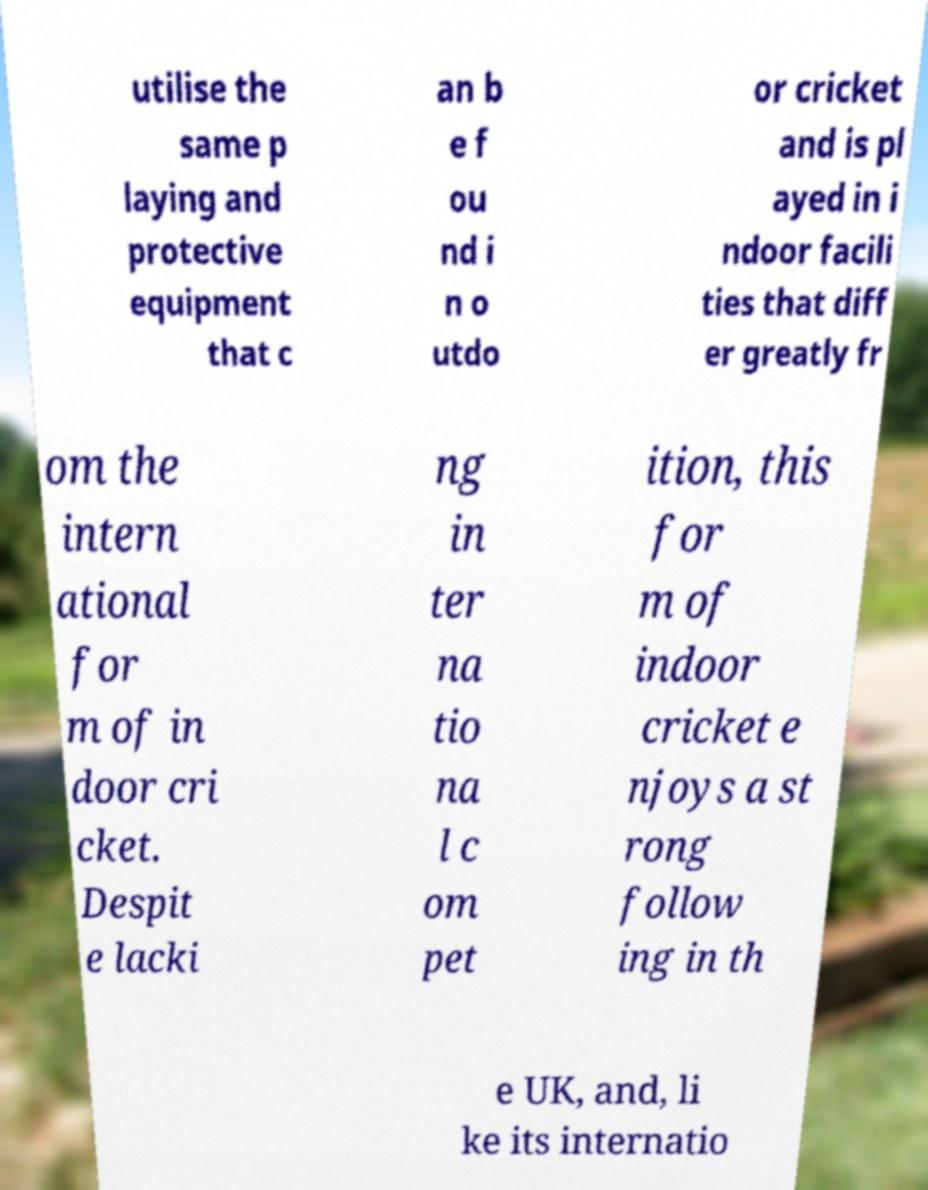Can you accurately transcribe the text from the provided image for me? utilise the same p laying and protective equipment that c an b e f ou nd i n o utdo or cricket and is pl ayed in i ndoor facili ties that diff er greatly fr om the intern ational for m of in door cri cket. Despit e lacki ng in ter na tio na l c om pet ition, this for m of indoor cricket e njoys a st rong follow ing in th e UK, and, li ke its internatio 